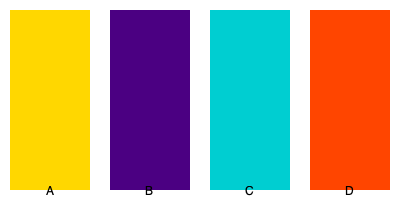In your collection of paintings by the artist, you have four pieces represented by the color palettes shown above. Which two paintings would create the most vibrant contrast when hung side by side? To determine which two paintings would create the most vibrant contrast, we need to consider the color theory principle of complementary colors. Complementary colors are pairs of colors that are opposite each other on the color wheel and create the highest contrast when placed side by side. Let's analyze the colors:

1. Painting A: Gold (#FFD700) - A warm, bright color
2. Painting B: Indigo (#4B0082) - A cool, dark color
3. Painting C: Turquoise (#00CED1) - A cool, bright color
4. Painting D: Orange-Red (#FF4500) - A warm, bright color

The most vibrant contrast would be created by pairing a warm color with its complementary cool color. In this case, the best pairing would be:

- Painting B (Indigo) and Painting D (Orange-Red)

Indigo is a dark, cool color, while Orange-Red is a bright, warm color. These colors are close to being complementary on the color wheel, creating a strong visual contrast when placed side by side.

The other combinations would not create as strong a contrast:
- A and C: Both are bright colors, but not complementary
- A and B: While contrasting in brightness, they are not complementary
- A and D: Both are warm colors
- B and C: Both are cool colors
- C and D: While contrasting, they are not as complementary as B and D

Therefore, hanging paintings B and D side by side would create the most vibrant contrast in your collection.
Answer: Paintings B and D 